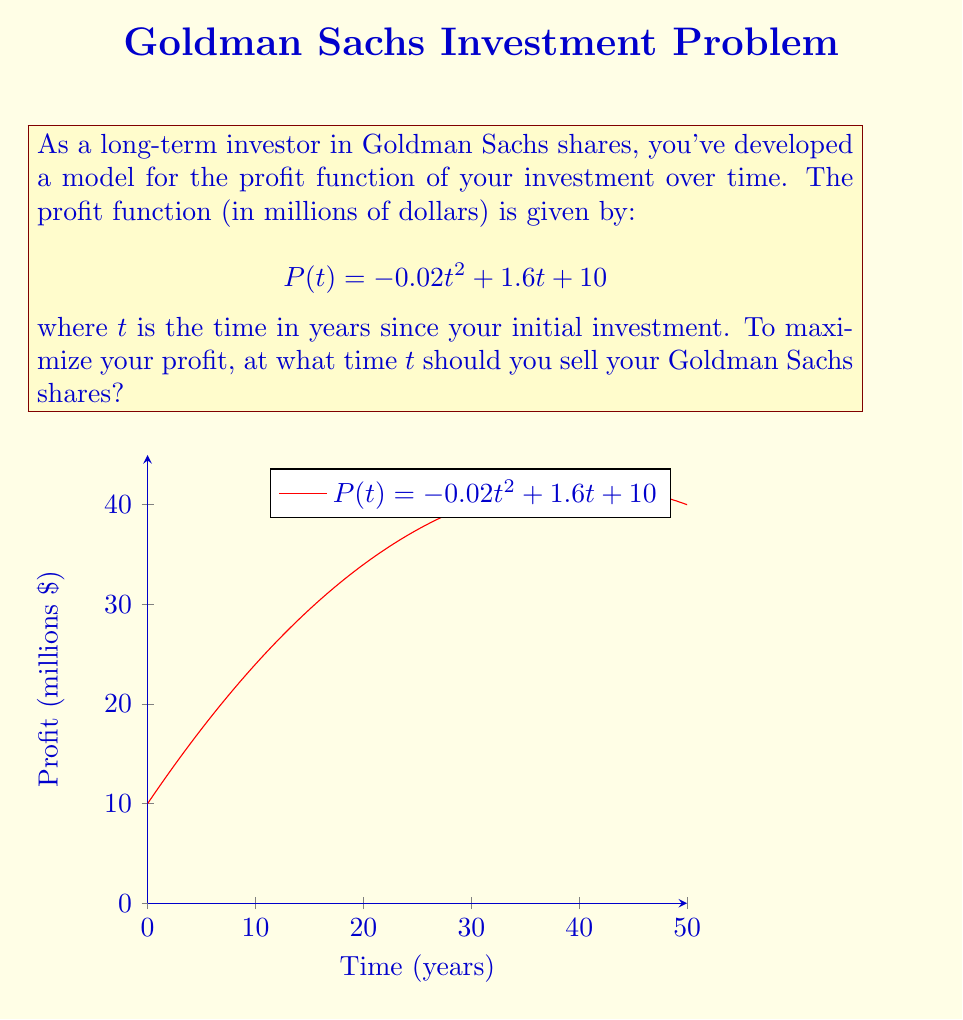Help me with this question. To find the optimal time to sell the shares, we need to find the maximum point of the quadratic profit function. This occurs at the vertex of the parabola.

Step 1: Identify the quadratic function in standard form.
The general form of a quadratic function is $f(x) = ax^2 + bx + c$
In this case, $P(t) = -0.02t^2 + 1.6t + 10$, where:
$a = -0.02$
$b = 1.6$
$c = 10$

Step 2: Calculate the t-coordinate of the vertex.
For a quadratic function, the x-coordinate (or in this case, t-coordinate) of the vertex is given by the formula:
$$t = -\frac{b}{2a}$$

Substituting the values:
$$t = -\frac{1.6}{2(-0.02)} = -\frac{1.6}{-0.04} = 40$$

Step 3: Verify the result.
We can verify that this is indeed a maximum by observing that $a$ is negative, which means the parabola opens downward and has a maximum rather than a minimum.

Therefore, the profit function reaches its maximum value when $t = 40$ years.
Answer: 40 years 